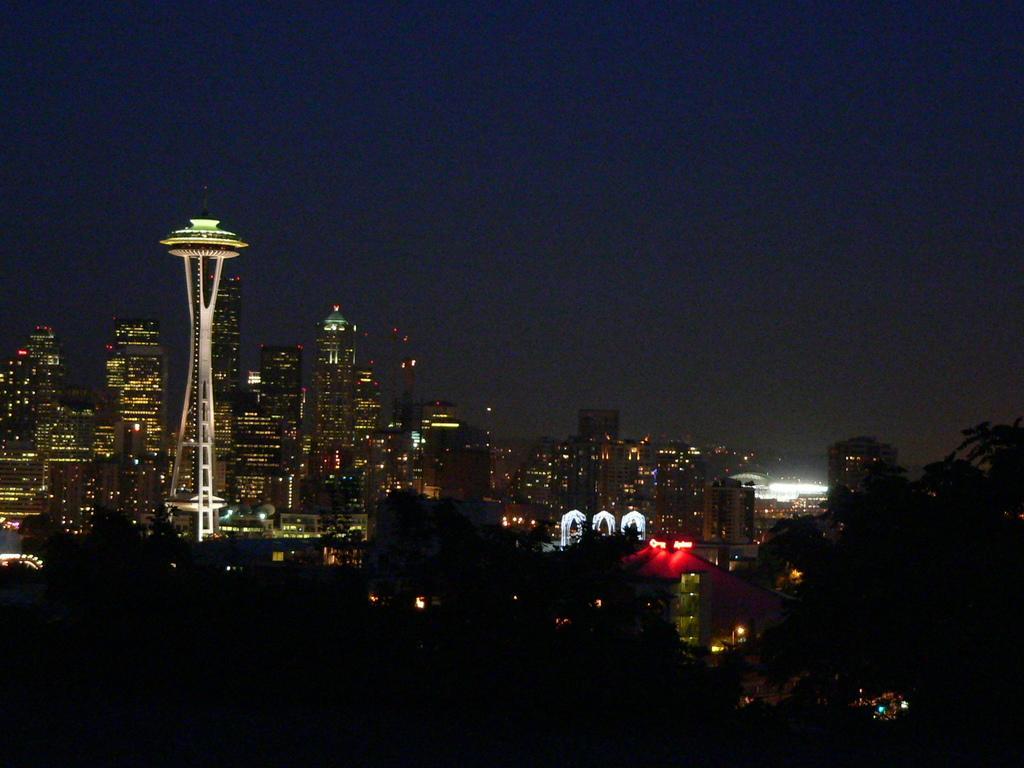Can you describe this image briefly? In the picture we can see a night view of buildings with lights and behind it we can see some tower buildings and sky. 